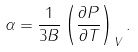Convert formula to latex. <formula><loc_0><loc_0><loc_500><loc_500>\alpha = \frac { 1 } { 3 B } \left ( \frac { \partial { P } } { \partial { T } } \right ) _ { V } .</formula> 